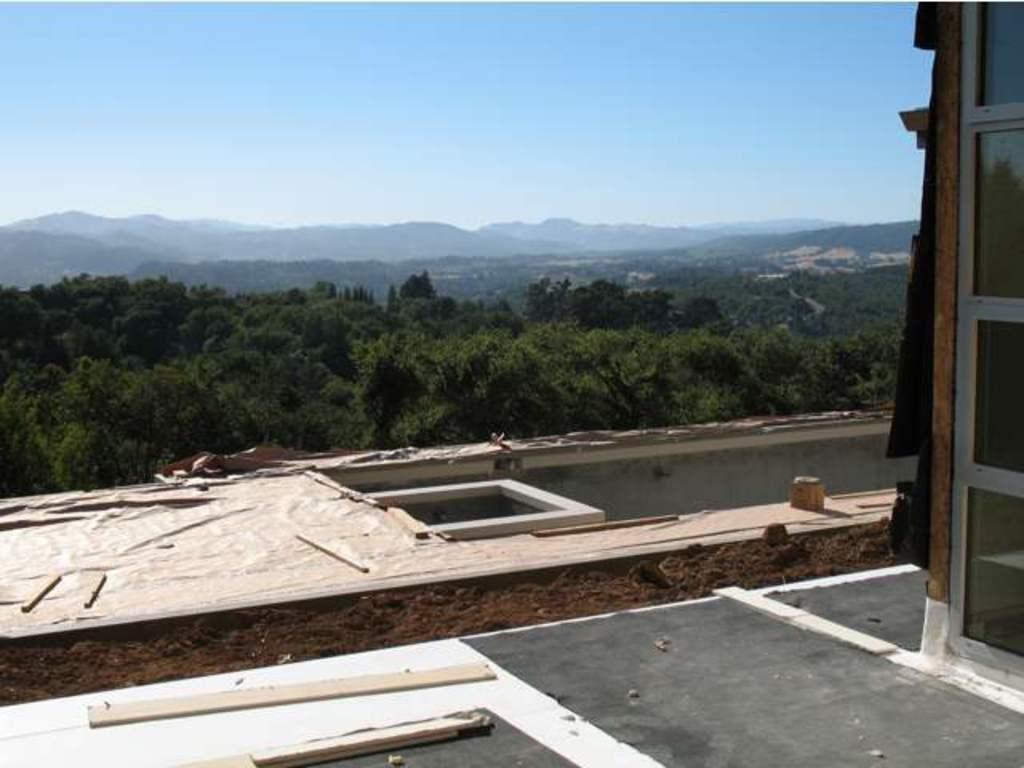Could you give a brief overview of what you see in this image? In this image I can see a building seems to be a terrace of a building under construction in the center of the image I can see trees and mountains. At the top of the image I can see the sky.  